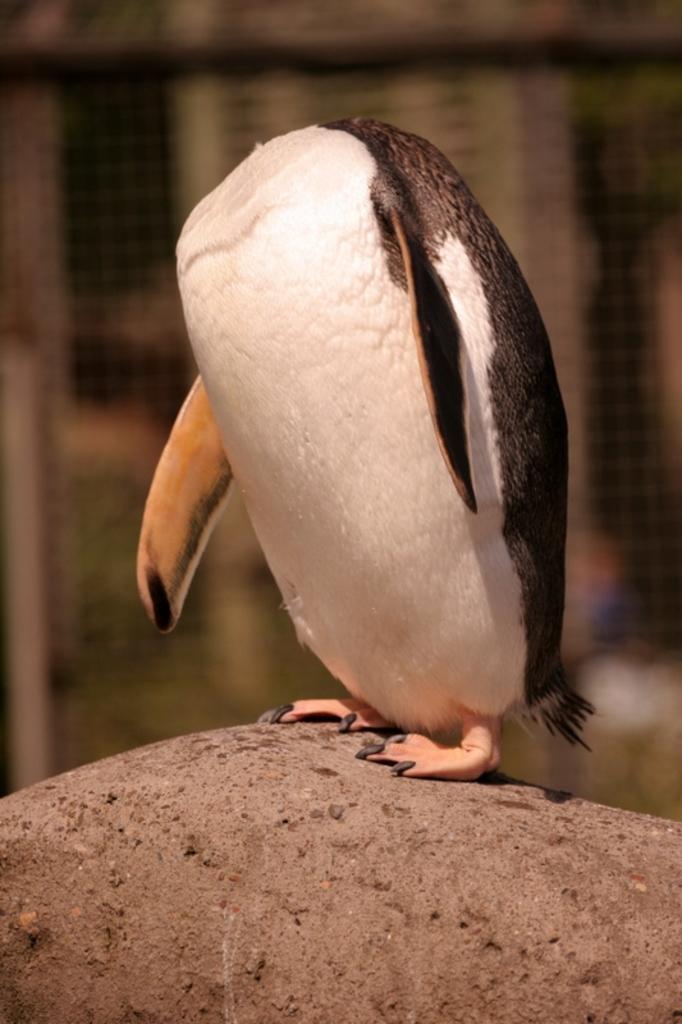Could you give a brief overview of what you see in this image? Inn this image there is a penguin standing on the rock. Behind it there is a fence. 